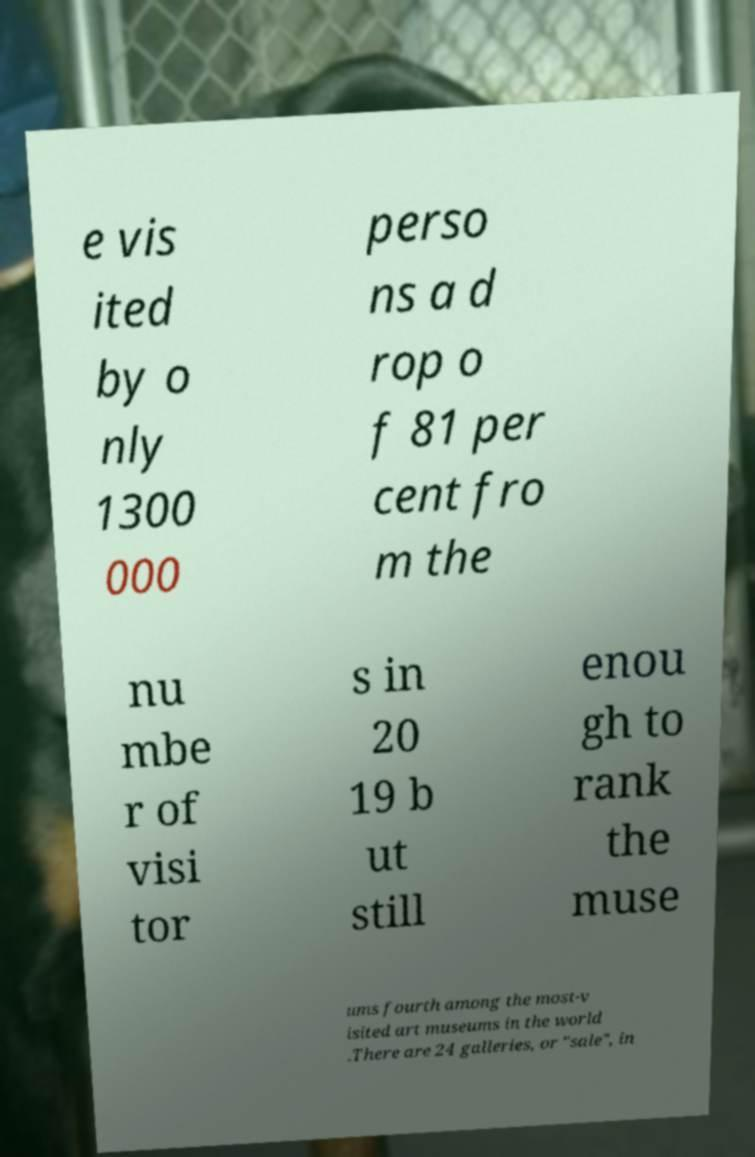Can you accurately transcribe the text from the provided image for me? e vis ited by o nly 1300 000 perso ns a d rop o f 81 per cent fro m the nu mbe r of visi tor s in 20 19 b ut still enou gh to rank the muse ums fourth among the most-v isited art museums in the world .There are 24 galleries, or "sale", in 